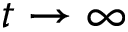<formula> <loc_0><loc_0><loc_500><loc_500>t \to \infty</formula> 